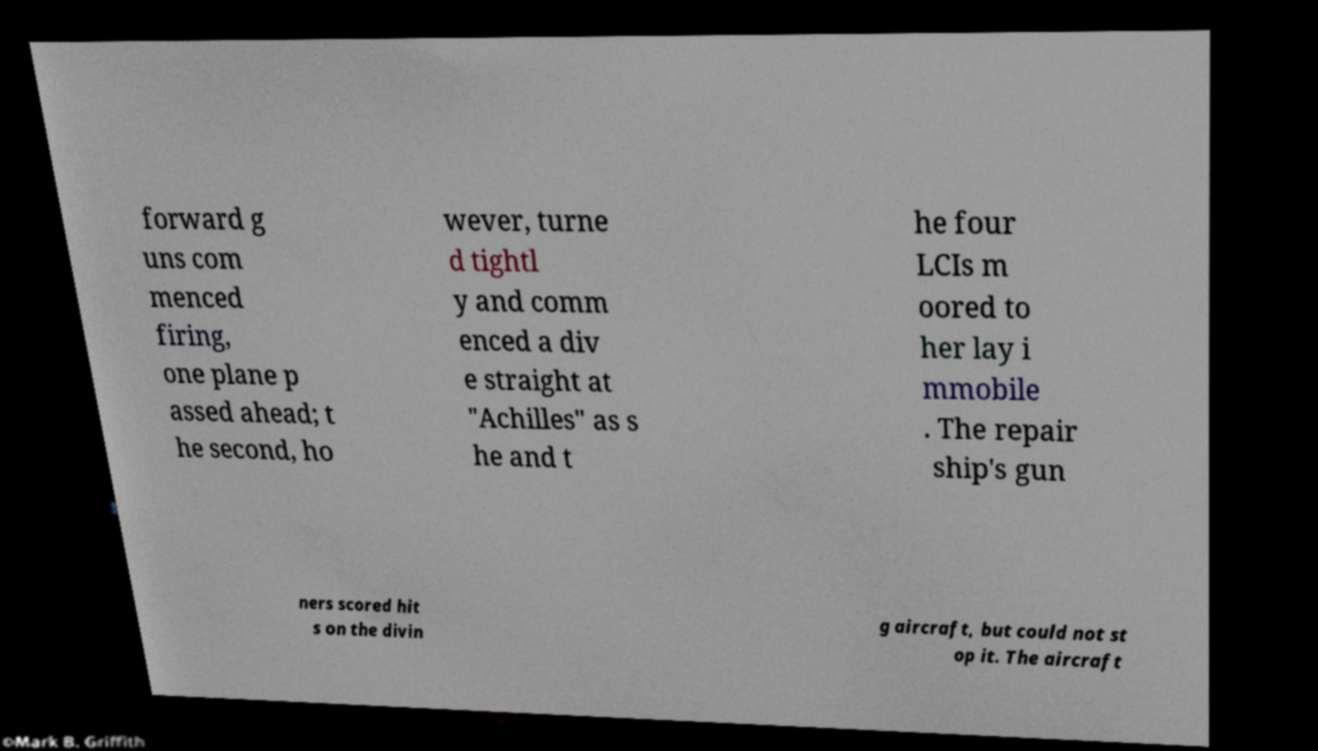Can you accurately transcribe the text from the provided image for me? forward g uns com menced firing, one plane p assed ahead; t he second, ho wever, turne d tightl y and comm enced a div e straight at "Achilles" as s he and t he four LCIs m oored to her lay i mmobile . The repair ship's gun ners scored hit s on the divin g aircraft, but could not st op it. The aircraft 